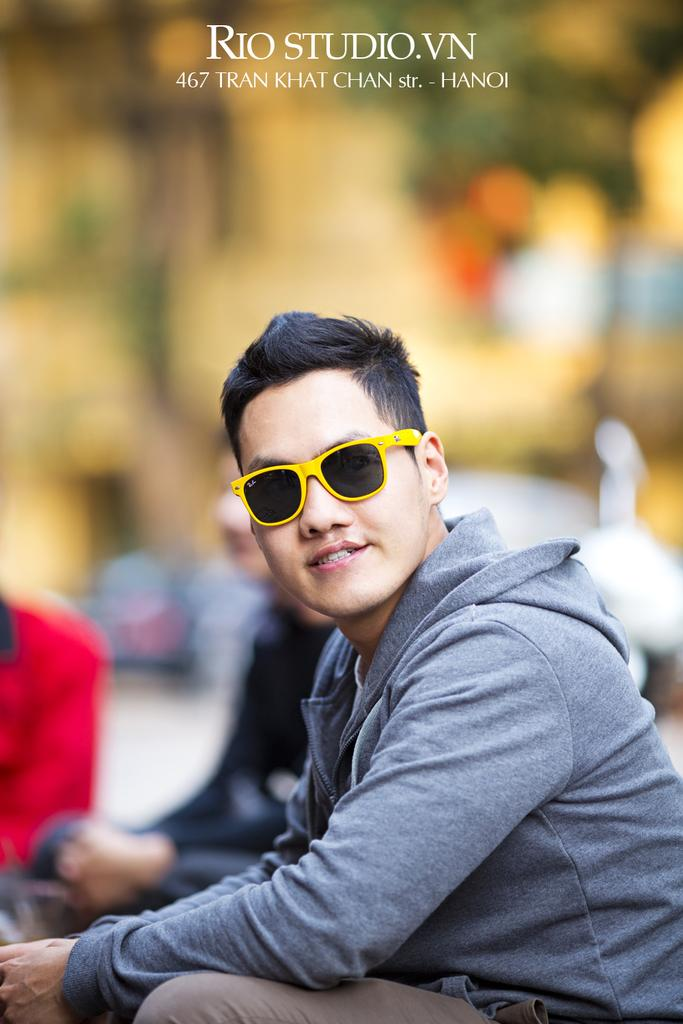What is the main subject of the image? There is a person in the image. Can you describe the person's appearance? The person is wearing clothes and sunglasses. What is written at the top of the image? There is text at the top of the image. How would you describe the background of the image? The background of the image is blurred. What type of wood is the person using to derive pleasure in the image? There is no wood or indication of pleasure-seeking behavior present in the image. 